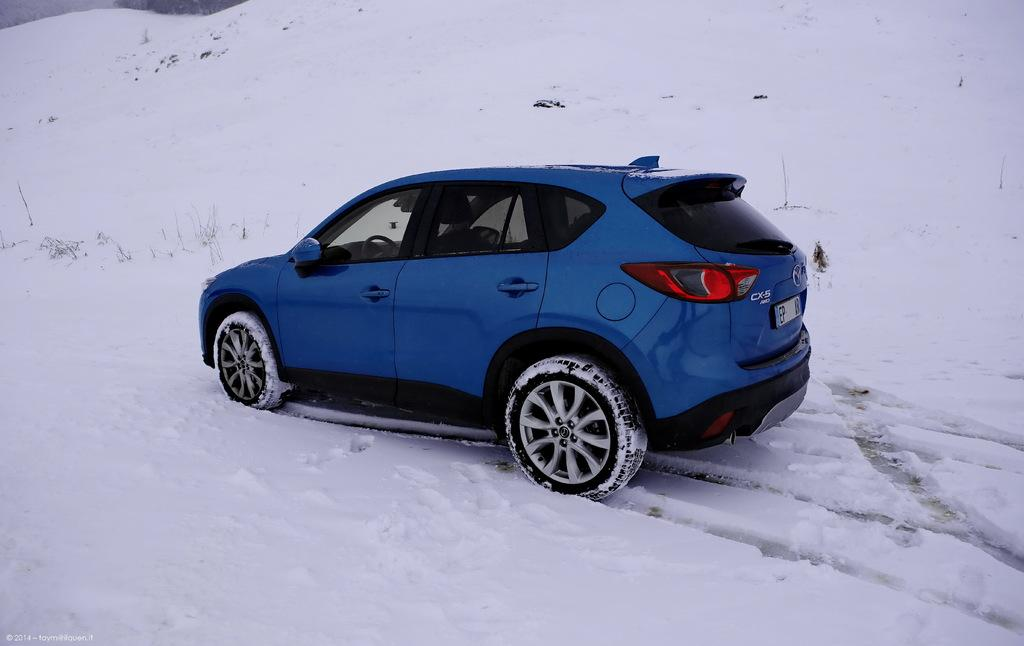What is the main subject of the image? There is a vehicle in the image. What colors are used to paint the vehicle? The vehicle is blue and black in color. What is the weather like in the image? There is snow everywhere in the image. What color is the snow? The snow is white in color. What year was the vehicle manufactured, as indicated by the detail on the side of the vehicle? There is no detail on the side of the vehicle that indicates the year of manufacture. How big is the snowflake in the image? There is no specific snowflake visible in the image, as it shows snow everywhere. 